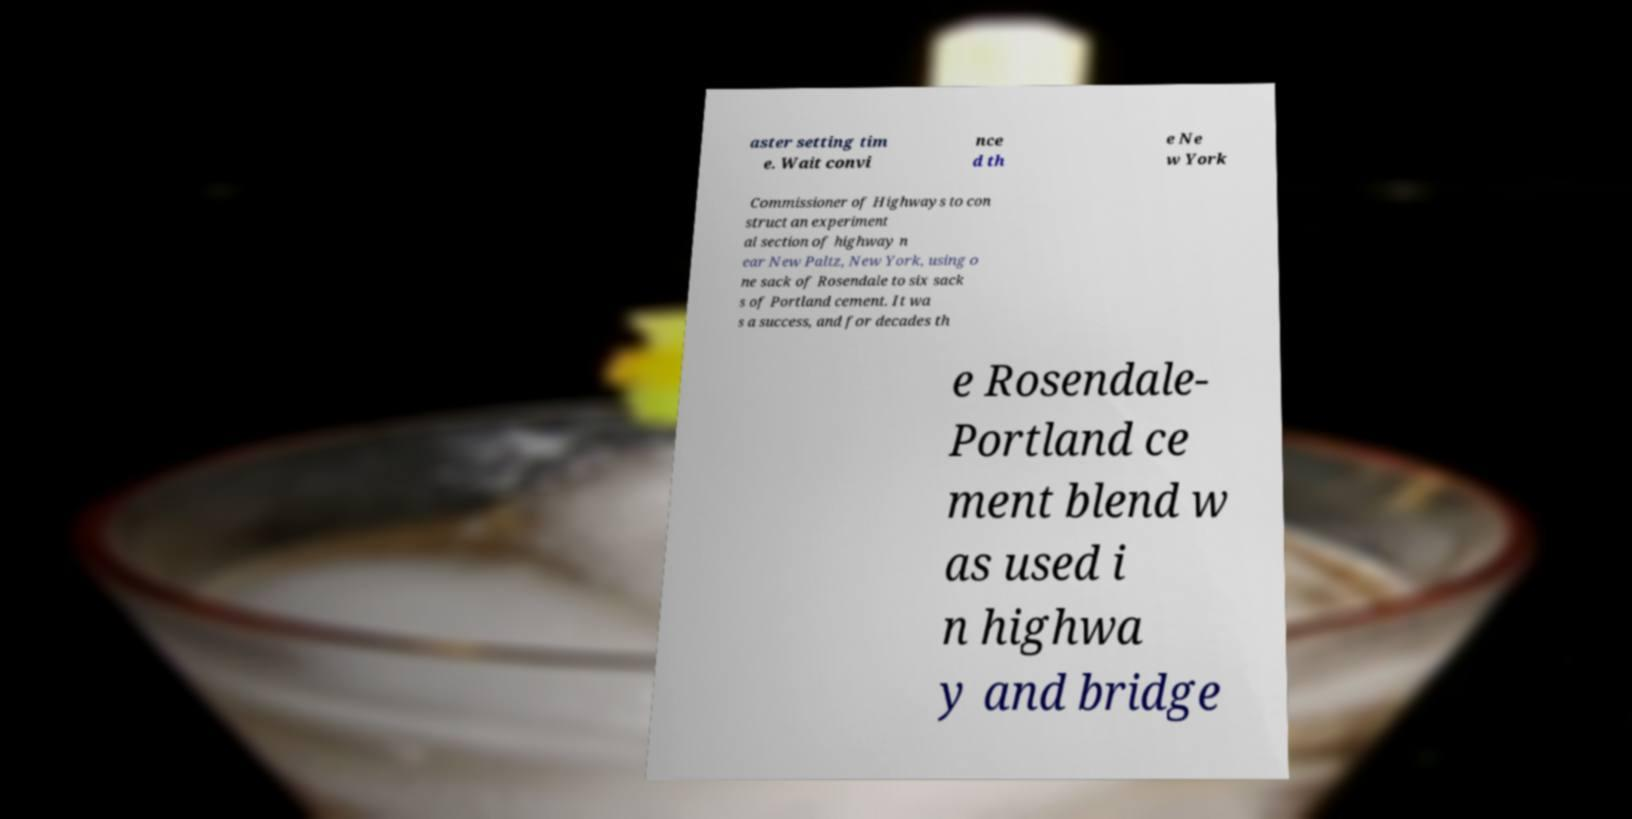Can you accurately transcribe the text from the provided image for me? aster setting tim e. Wait convi nce d th e Ne w York Commissioner of Highways to con struct an experiment al section of highway n ear New Paltz, New York, using o ne sack of Rosendale to six sack s of Portland cement. It wa s a success, and for decades th e Rosendale- Portland ce ment blend w as used i n highwa y and bridge 